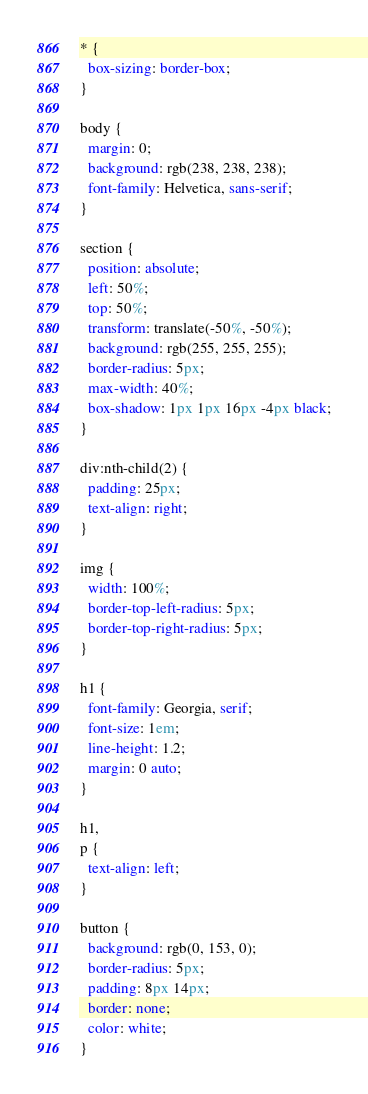<code> <loc_0><loc_0><loc_500><loc_500><_CSS_>* {
  box-sizing: border-box;
}

body {
  margin: 0;
  background: rgb(238, 238, 238);
  font-family: Helvetica, sans-serif;
}

section {
  position: absolute;
  left: 50%;
  top: 50%;
  transform: translate(-50%, -50%);
  background: rgb(255, 255, 255);
  border-radius: 5px;
  max-width: 40%;
  box-shadow: 1px 1px 16px -4px black;
}

div:nth-child(2) {
  padding: 25px;
  text-align: right;
}

img {
  width: 100%;
  border-top-left-radius: 5px;
  border-top-right-radius: 5px;
}

h1 {
  font-family: Georgia, serif;
  font-size: 1em;
  line-height: 1.2;
  margin: 0 auto;
}

h1,
p {
  text-align: left;
}

button {
  background: rgb(0, 153, 0);
  border-radius: 5px;
  padding: 8px 14px;
  border: none;
  color: white;
}
</code> 